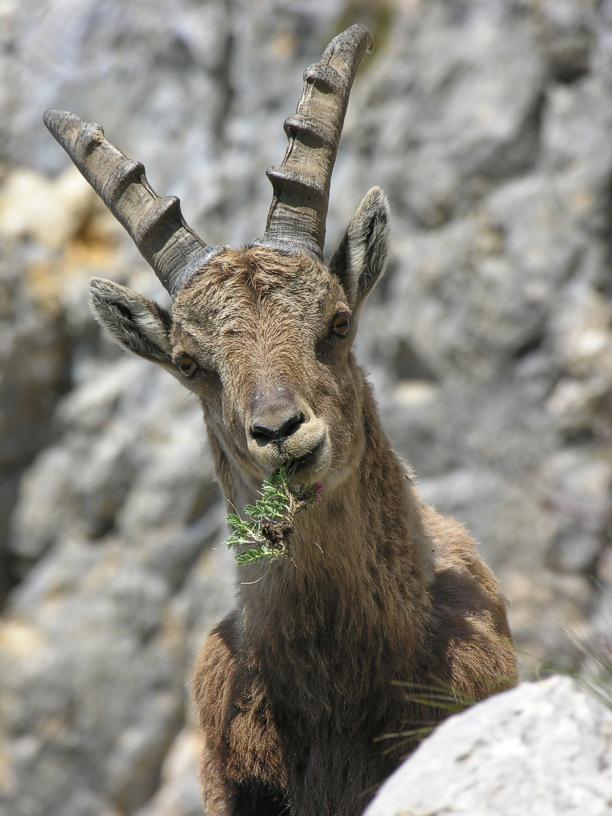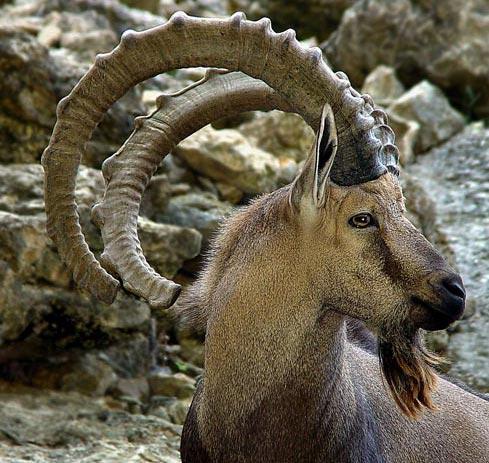The first image is the image on the left, the second image is the image on the right. Analyze the images presented: Is the assertion "both animals are facing the same direction." valid? Answer yes or no. No. 